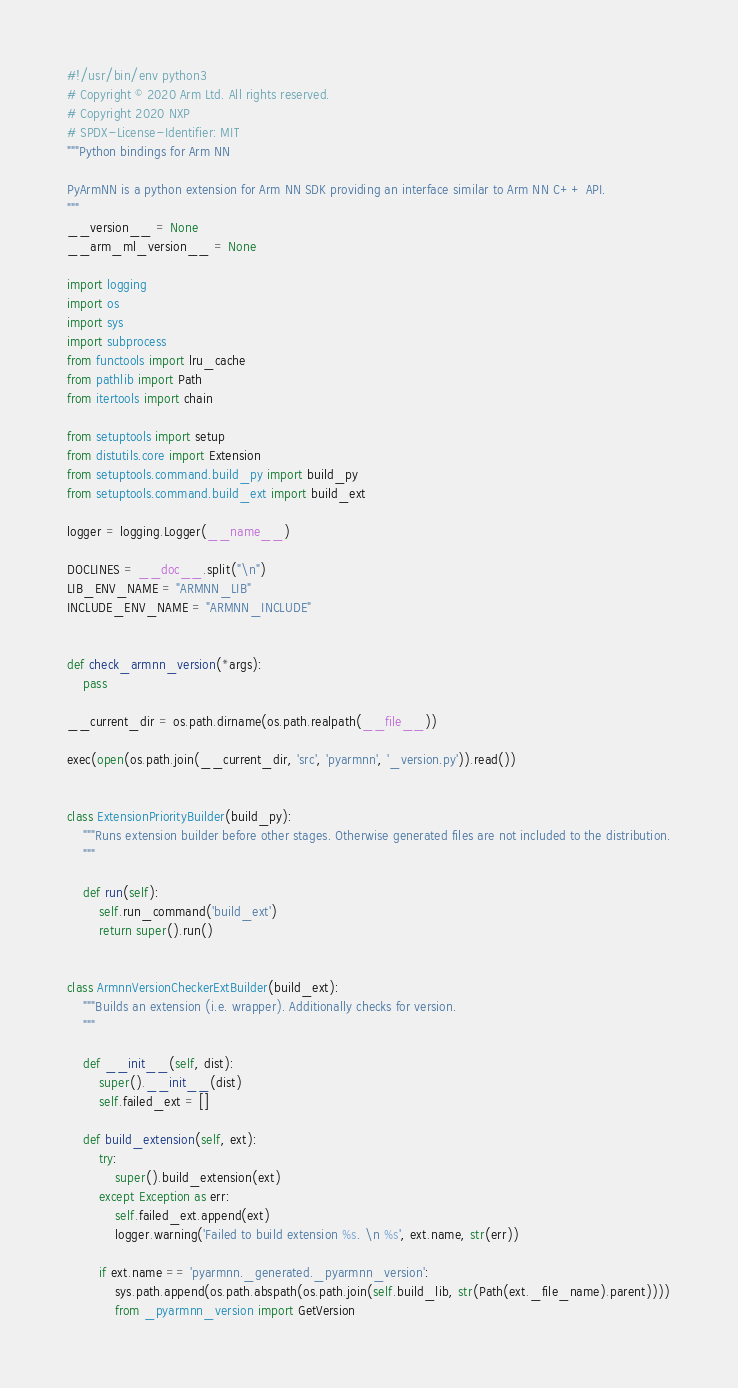Convert code to text. <code><loc_0><loc_0><loc_500><loc_500><_Python_>#!/usr/bin/env python3
# Copyright © 2020 Arm Ltd. All rights reserved.
# Copyright 2020 NXP
# SPDX-License-Identifier: MIT
"""Python bindings for Arm NN

PyArmNN is a python extension for Arm NN SDK providing an interface similar to Arm NN C++ API.
"""
__version__ = None
__arm_ml_version__ = None

import logging
import os
import sys
import subprocess
from functools import lru_cache
from pathlib import Path
from itertools import chain

from setuptools import setup
from distutils.core import Extension
from setuptools.command.build_py import build_py
from setuptools.command.build_ext import build_ext

logger = logging.Logger(__name__)

DOCLINES = __doc__.split("\n")
LIB_ENV_NAME = "ARMNN_LIB"
INCLUDE_ENV_NAME = "ARMNN_INCLUDE"


def check_armnn_version(*args):
    pass

__current_dir = os.path.dirname(os.path.realpath(__file__))

exec(open(os.path.join(__current_dir, 'src', 'pyarmnn', '_version.py')).read())


class ExtensionPriorityBuilder(build_py):
    """Runs extension builder before other stages. Otherwise generated files are not included to the distribution.
    """

    def run(self):
        self.run_command('build_ext')
        return super().run()


class ArmnnVersionCheckerExtBuilder(build_ext):
    """Builds an extension (i.e. wrapper). Additionally checks for version.
    """

    def __init__(self, dist):
        super().__init__(dist)
        self.failed_ext = []

    def build_extension(self, ext):
        try:
            super().build_extension(ext)
        except Exception as err:
            self.failed_ext.append(ext)
            logger.warning('Failed to build extension %s. \n %s', ext.name, str(err))

        if ext.name == 'pyarmnn._generated._pyarmnn_version':
            sys.path.append(os.path.abspath(os.path.join(self.build_lib, str(Path(ext._file_name).parent))))
            from _pyarmnn_version import GetVersion</code> 